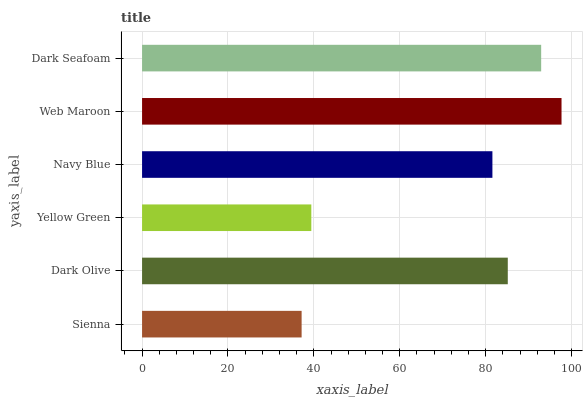Is Sienna the minimum?
Answer yes or no. Yes. Is Web Maroon the maximum?
Answer yes or no. Yes. Is Dark Olive the minimum?
Answer yes or no. No. Is Dark Olive the maximum?
Answer yes or no. No. Is Dark Olive greater than Sienna?
Answer yes or no. Yes. Is Sienna less than Dark Olive?
Answer yes or no. Yes. Is Sienna greater than Dark Olive?
Answer yes or no. No. Is Dark Olive less than Sienna?
Answer yes or no. No. Is Dark Olive the high median?
Answer yes or no. Yes. Is Navy Blue the low median?
Answer yes or no. Yes. Is Yellow Green the high median?
Answer yes or no. No. Is Dark Olive the low median?
Answer yes or no. No. 